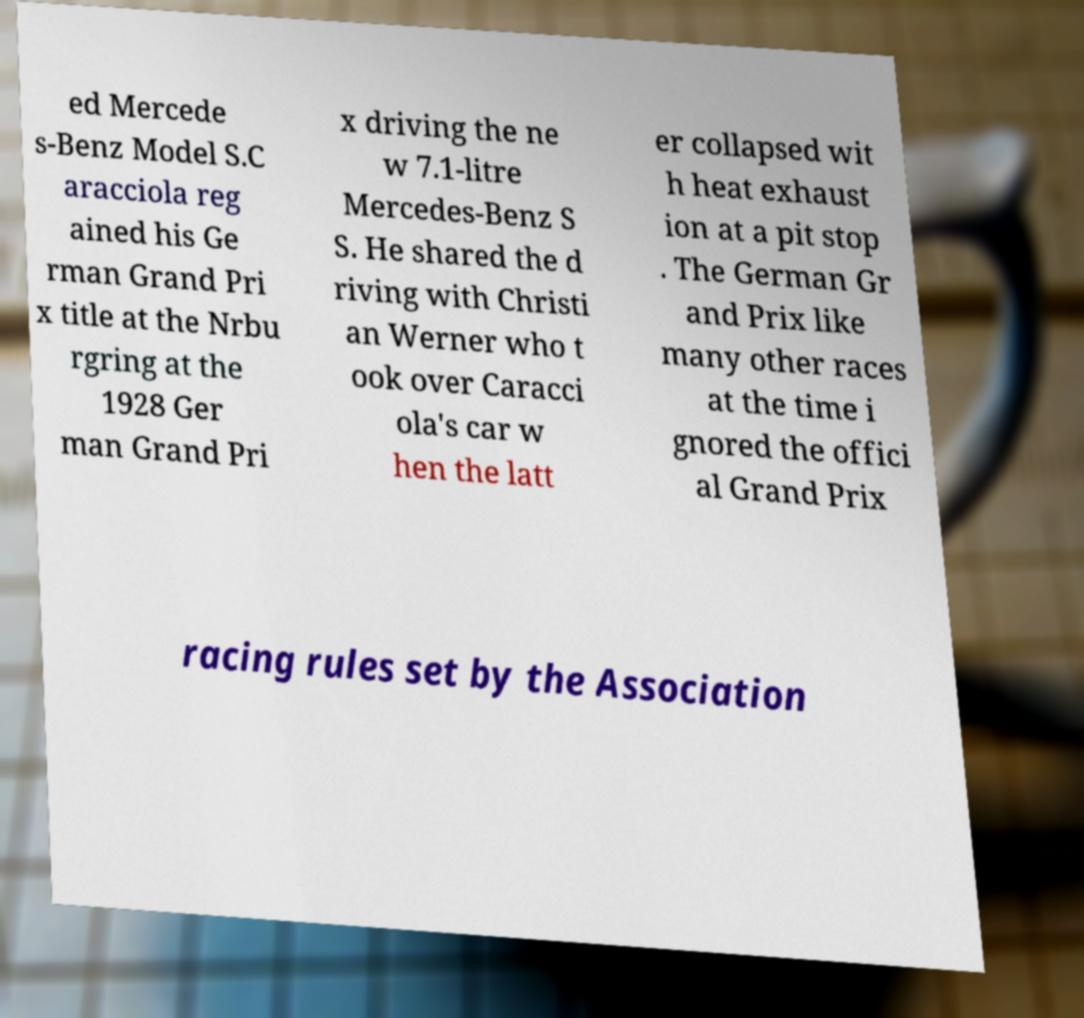Please identify and transcribe the text found in this image. ed Mercede s-Benz Model S.C aracciola reg ained his Ge rman Grand Pri x title at the Nrbu rgring at the 1928 Ger man Grand Pri x driving the ne w 7.1-litre Mercedes-Benz S S. He shared the d riving with Christi an Werner who t ook over Caracci ola's car w hen the latt er collapsed wit h heat exhaust ion at a pit stop . The German Gr and Prix like many other races at the time i gnored the offici al Grand Prix racing rules set by the Association 